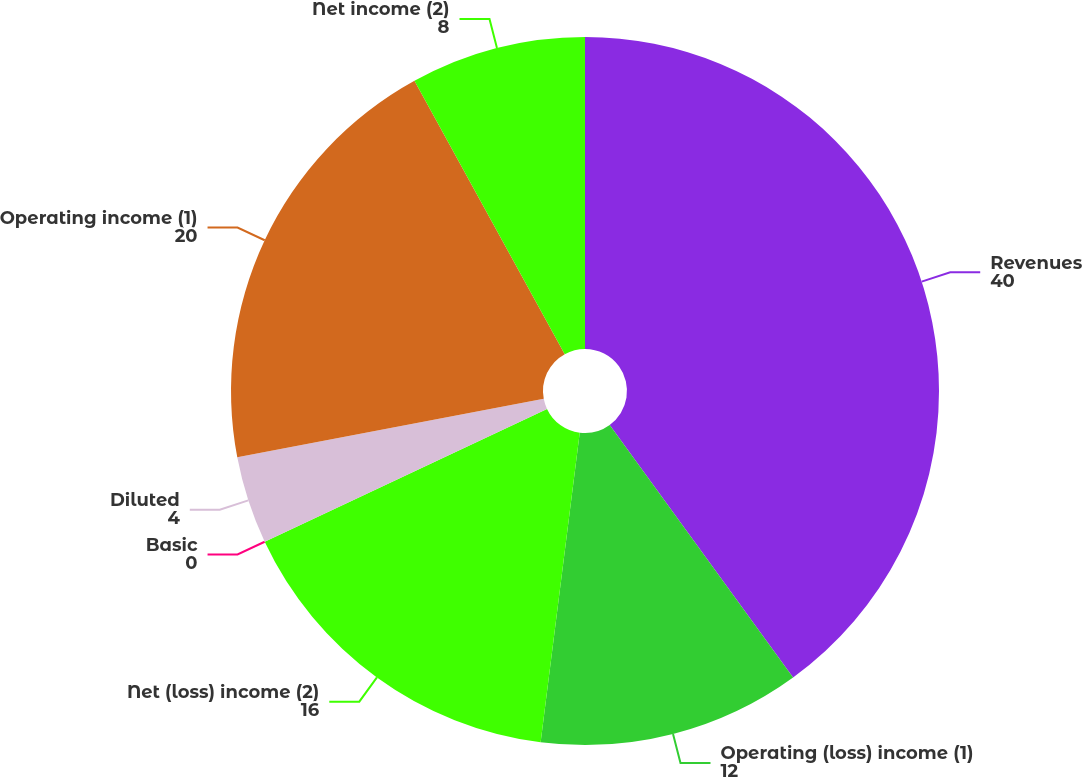Convert chart to OTSL. <chart><loc_0><loc_0><loc_500><loc_500><pie_chart><fcel>Revenues<fcel>Operating (loss) income (1)<fcel>Net (loss) income (2)<fcel>Basic<fcel>Diluted<fcel>Operating income (1)<fcel>Net income (2)<nl><fcel>40.0%<fcel>12.0%<fcel>16.0%<fcel>0.0%<fcel>4.0%<fcel>20.0%<fcel>8.0%<nl></chart> 